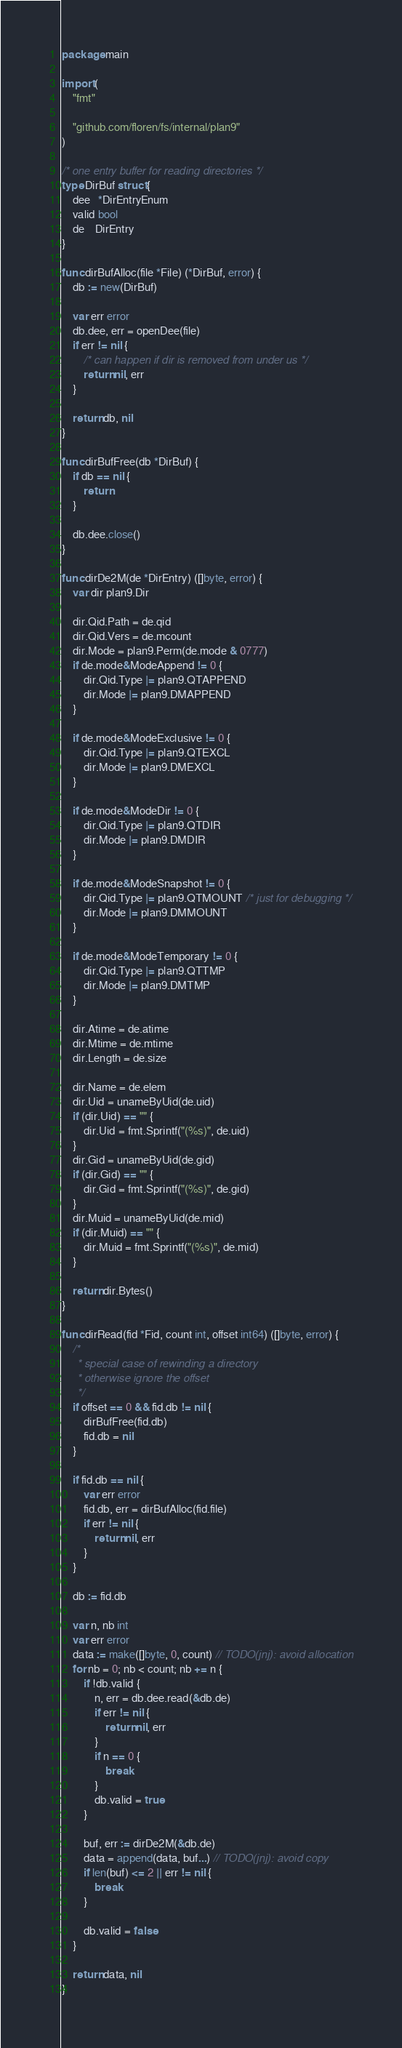Convert code to text. <code><loc_0><loc_0><loc_500><loc_500><_Go_>package main

import (
	"fmt"

	"github.com/floren/fs/internal/plan9"
)

/* one entry buffer for reading directories */
type DirBuf struct {
	dee   *DirEntryEnum
	valid bool
	de    DirEntry
}

func dirBufAlloc(file *File) (*DirBuf, error) {
	db := new(DirBuf)

	var err error
	db.dee, err = openDee(file)
	if err != nil {
		/* can happen if dir is removed from under us */
		return nil, err
	}

	return db, nil
}

func dirBufFree(db *DirBuf) {
	if db == nil {
		return
	}

	db.dee.close()
}

func dirDe2M(de *DirEntry) ([]byte, error) {
	var dir plan9.Dir

	dir.Qid.Path = de.qid
	dir.Qid.Vers = de.mcount
	dir.Mode = plan9.Perm(de.mode & 0777)
	if de.mode&ModeAppend != 0 {
		dir.Qid.Type |= plan9.QTAPPEND
		dir.Mode |= plan9.DMAPPEND
	}

	if de.mode&ModeExclusive != 0 {
		dir.Qid.Type |= plan9.QTEXCL
		dir.Mode |= plan9.DMEXCL
	}

	if de.mode&ModeDir != 0 {
		dir.Qid.Type |= plan9.QTDIR
		dir.Mode |= plan9.DMDIR
	}

	if de.mode&ModeSnapshot != 0 {
		dir.Qid.Type |= plan9.QTMOUNT /* just for debugging */
		dir.Mode |= plan9.DMMOUNT
	}

	if de.mode&ModeTemporary != 0 {
		dir.Qid.Type |= plan9.QTTMP
		dir.Mode |= plan9.DMTMP
	}

	dir.Atime = de.atime
	dir.Mtime = de.mtime
	dir.Length = de.size

	dir.Name = de.elem
	dir.Uid = unameByUid(de.uid)
	if (dir.Uid) == "" {
		dir.Uid = fmt.Sprintf("(%s)", de.uid)
	}
	dir.Gid = unameByUid(de.gid)
	if (dir.Gid) == "" {
		dir.Gid = fmt.Sprintf("(%s)", de.gid)
	}
	dir.Muid = unameByUid(de.mid)
	if (dir.Muid) == "" {
		dir.Muid = fmt.Sprintf("(%s)", de.mid)
	}

	return dir.Bytes()
}

func dirRead(fid *Fid, count int, offset int64) ([]byte, error) {
	/*
	 * special case of rewinding a directory
	 * otherwise ignore the offset
	 */
	if offset == 0 && fid.db != nil {
		dirBufFree(fid.db)
		fid.db = nil
	}

	if fid.db == nil {
		var err error
		fid.db, err = dirBufAlloc(fid.file)
		if err != nil {
			return nil, err
		}
	}

	db := fid.db

	var n, nb int
	var err error
	data := make([]byte, 0, count) // TODO(jnj): avoid allocation
	for nb = 0; nb < count; nb += n {
		if !db.valid {
			n, err = db.dee.read(&db.de)
			if err != nil {
				return nil, err
			}
			if n == 0 {
				break
			}
			db.valid = true
		}

		buf, err := dirDe2M(&db.de)
		data = append(data, buf...) // TODO(jnj): avoid copy
		if len(buf) <= 2 || err != nil {
			break
		}

		db.valid = false
	}

	return data, nil
}
</code> 